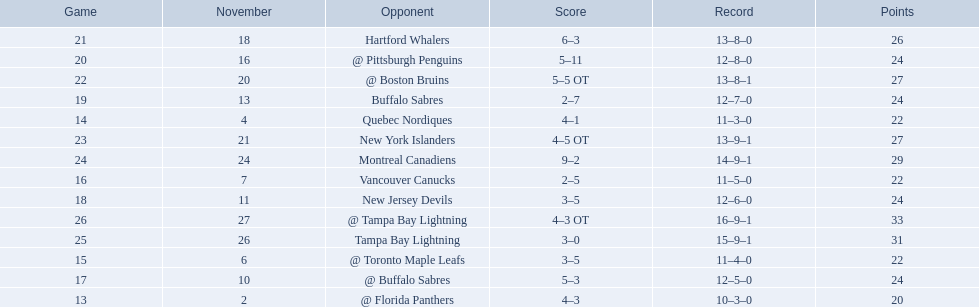What were the scores of the 1993-94 philadelphia flyers season? 4–3, 4–1, 3–5, 2–5, 5–3, 3–5, 2–7, 5–11, 6–3, 5–5 OT, 4–5 OT, 9–2, 3–0, 4–3 OT. Which of these teams had the score 4-5 ot? New York Islanders. 